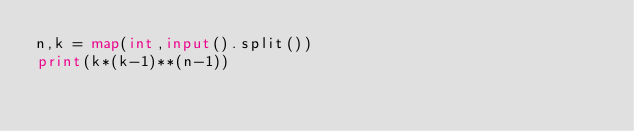Convert code to text. <code><loc_0><loc_0><loc_500><loc_500><_Python_>n,k = map(int,input().split())
print(k*(k-1)**(n-1))
</code> 